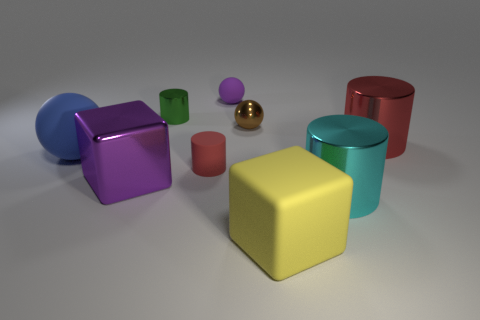There is another cylinder that is the same color as the small rubber cylinder; what is its material?
Offer a very short reply. Metal. What number of large yellow cubes have the same material as the small brown sphere?
Your answer should be compact. 0. Does the matte ball to the right of the green cylinder have the same size as the yellow cube?
Ensure brevity in your answer.  No. The other tiny thing that is made of the same material as the small brown thing is what color?
Provide a succinct answer. Green. Is there any other thing that is the same size as the red matte thing?
Offer a terse response. Yes. There is a small green shiny thing; how many big blue rubber objects are on the right side of it?
Provide a short and direct response. 0. Do the rubber object behind the blue sphere and the metal thing that is behind the small brown thing have the same color?
Give a very brief answer. No. There is a matte thing that is the same shape as the tiny green metallic thing; what is its color?
Your answer should be very brief. Red. Is there any other thing that has the same shape as the tiny red object?
Ensure brevity in your answer.  Yes. Does the red thing that is on the left side of the yellow block have the same shape as the large thing behind the big ball?
Provide a succinct answer. Yes. 